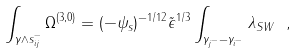<formula> <loc_0><loc_0><loc_500><loc_500>\int _ { \gamma \wedge s _ { i j } ^ { - } } \Omega ^ { ( 3 , 0 ) } = ( - \psi _ { s } ) ^ { - 1 / 1 2 } \tilde { \epsilon } ^ { 1 / 3 } \int _ { \gamma _ { j ^ { - } } - \gamma _ { i ^ { - } } } \lambda _ { S W } \ ,</formula> 